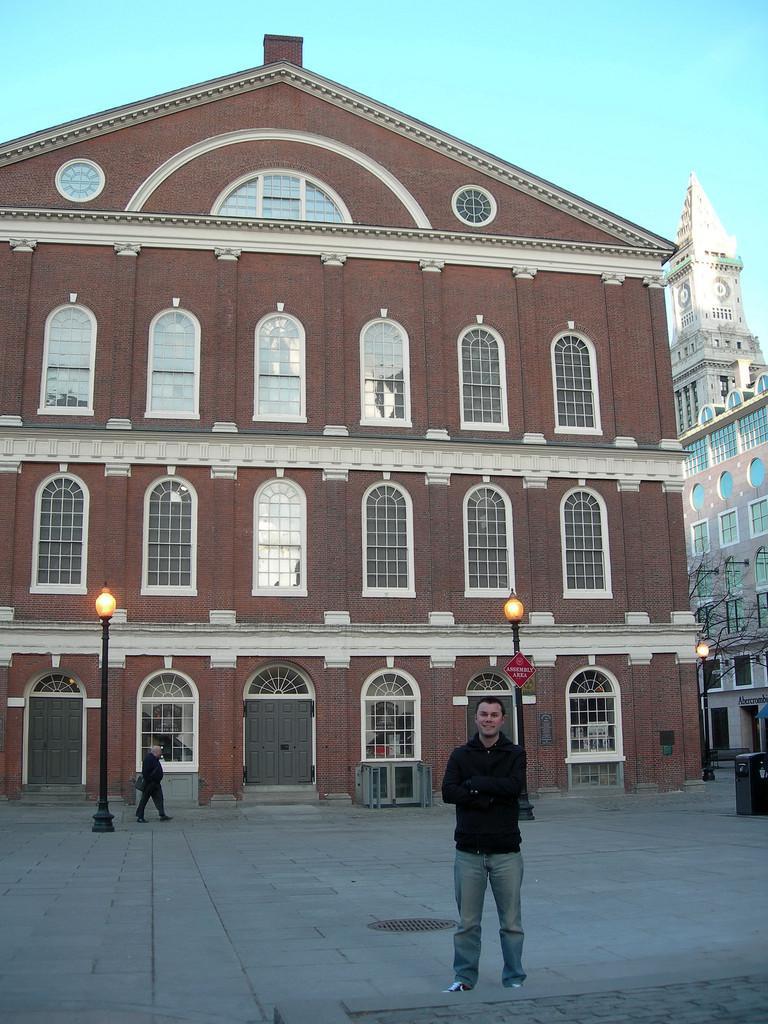Could you give a brief overview of what you see in this image? At the bottom of the image, we can see a person is standing on a path and smiling. Background we can see a person is walking through the walkway. Here we can see light poles, board, buildings, walls, windows, doors, stairs, tree and dustbin. Top of the image, we can see the sky. 